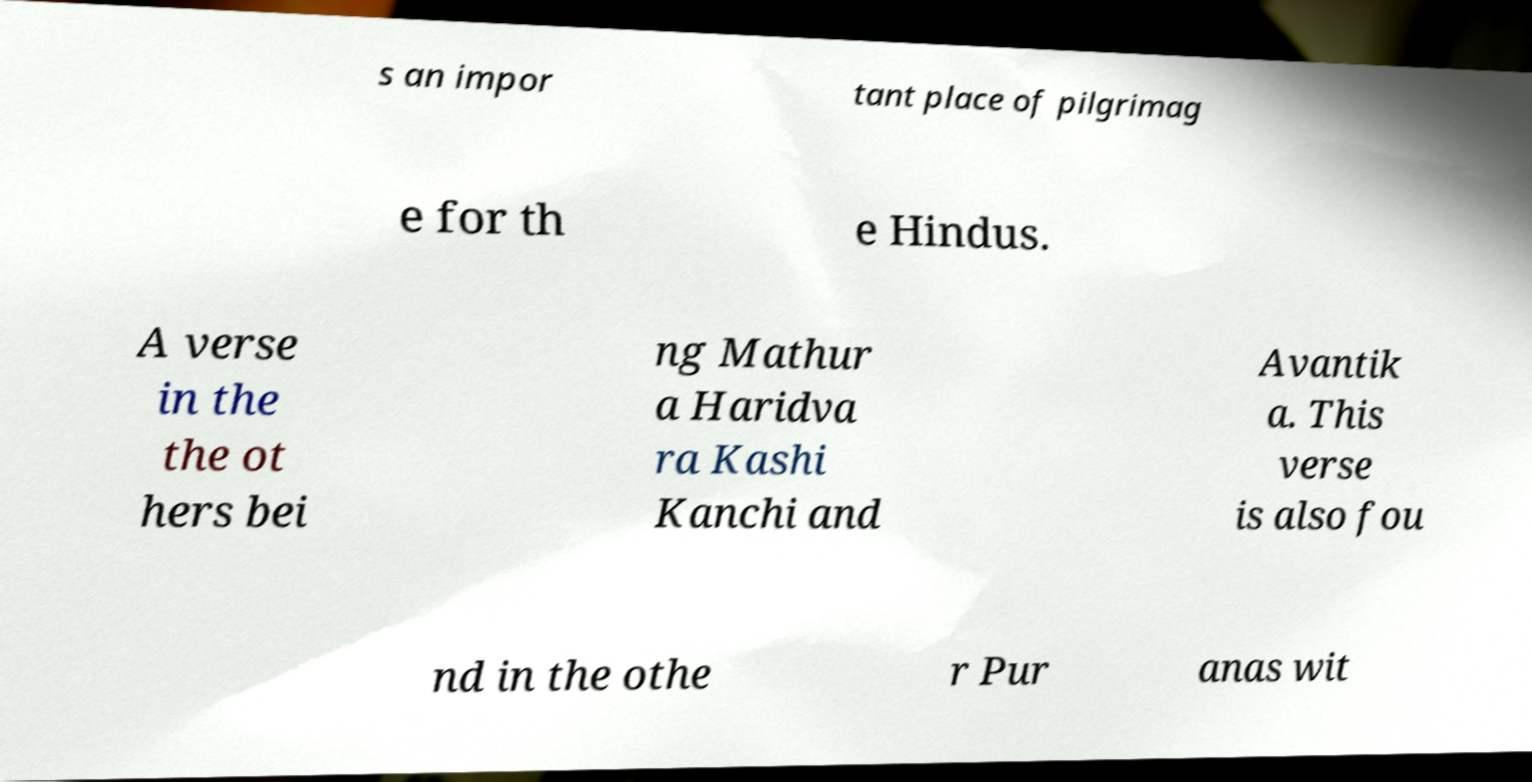I need the written content from this picture converted into text. Can you do that? s an impor tant place of pilgrimag e for th e Hindus. A verse in the the ot hers bei ng Mathur a Haridva ra Kashi Kanchi and Avantik a. This verse is also fou nd in the othe r Pur anas wit 